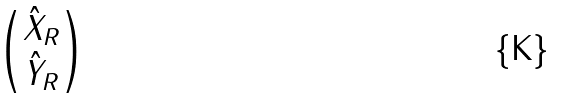<formula> <loc_0><loc_0><loc_500><loc_500>\begin{pmatrix} \hat { X } _ { R } \\ \hat { Y } _ { R } \end{pmatrix}</formula> 